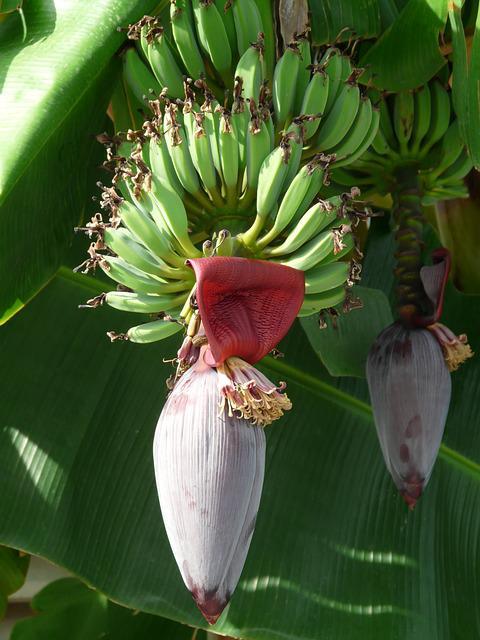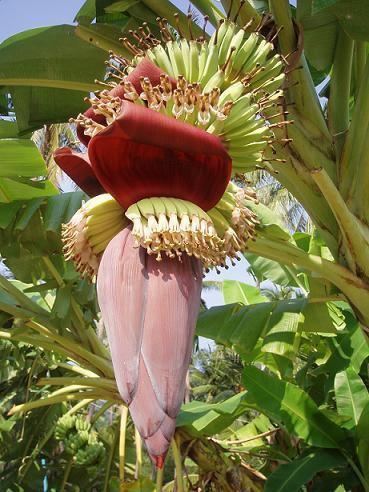The first image is the image on the left, the second image is the image on the right. Considering the images on both sides, is "Each image shows a large purplish flower beneath bunches of green bananas, but no image shows a flower with more than three petals fanning out." valid? Answer yes or no. Yes. 